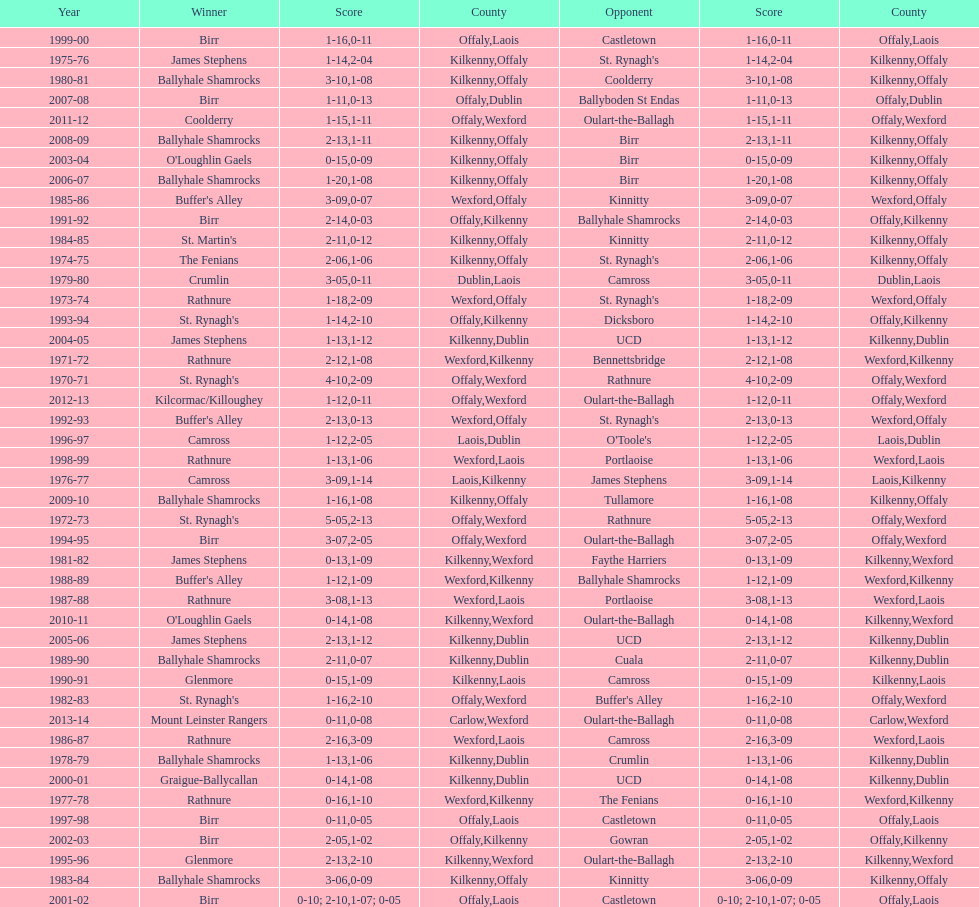How many consecutive years did rathnure win? 2. 